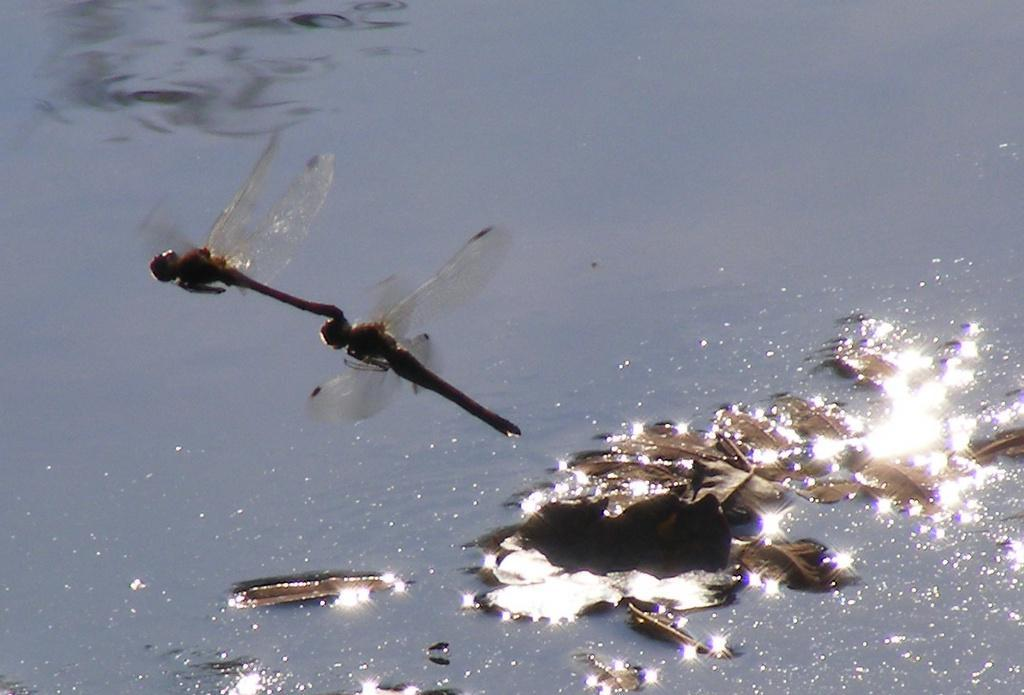What insects can be seen in the foreground of the image? There are two dragonflies in the air in the foreground of the image. What is present on the water in the background of the image? There are leaves on the water in the background of the image. What type of dust can be seen on the dragonflies in the image? There is no dust present on the dragonflies in the image. Can you hear the dragonflies coughing in the image? Dragonflies do not have the ability to cough, and there is no sound in the image. 